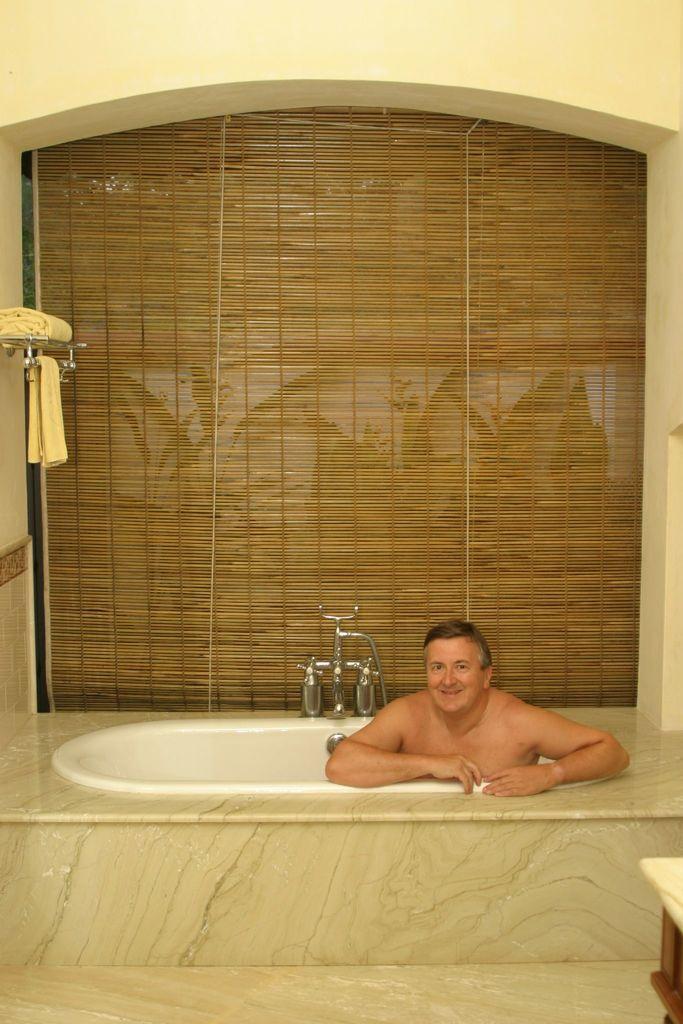Describe this image in one or two sentences. In this picture we can see a man in a bathtub and smiling and at the back of him we can see taps, towels, curtain, wall and in front of him we can see an object on the floor. 